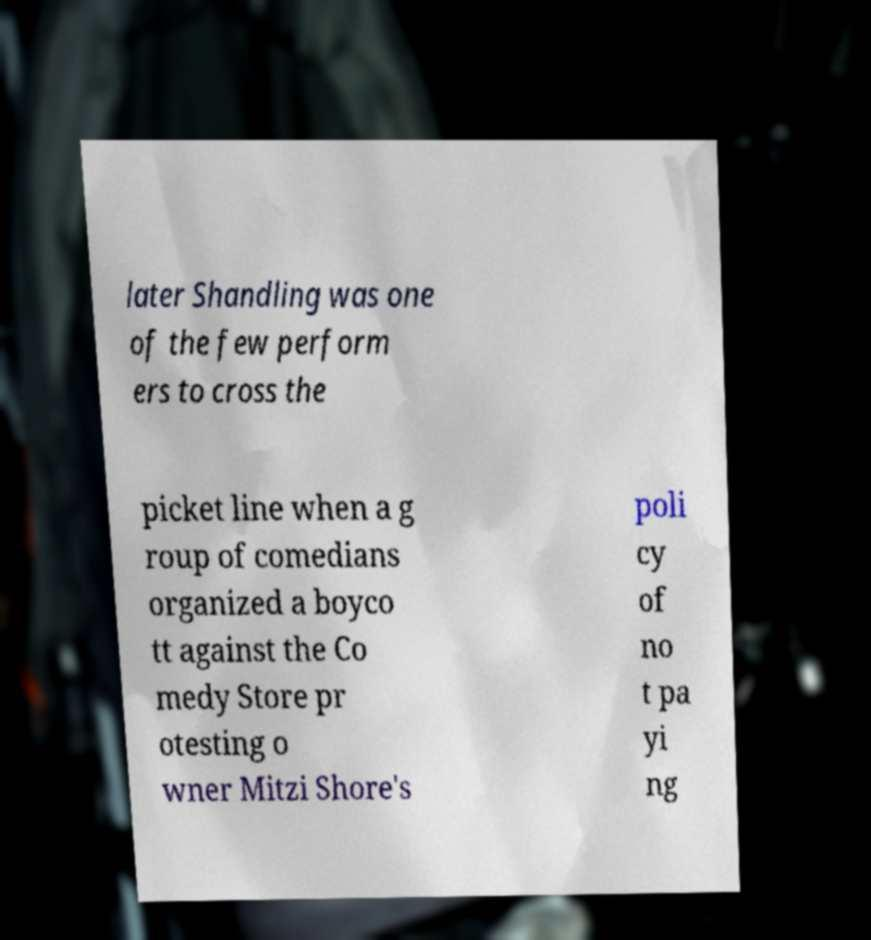Can you read and provide the text displayed in the image?This photo seems to have some interesting text. Can you extract and type it out for me? later Shandling was one of the few perform ers to cross the picket line when a g roup of comedians organized a boyco tt against the Co medy Store pr otesting o wner Mitzi Shore's poli cy of no t pa yi ng 